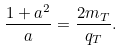<formula> <loc_0><loc_0><loc_500><loc_500>\frac { 1 + a ^ { 2 } } { a } = \frac { 2 m _ { T } } { q _ { T } } .</formula> 